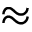<formula> <loc_0><loc_0><loc_500><loc_500>\approx</formula> 